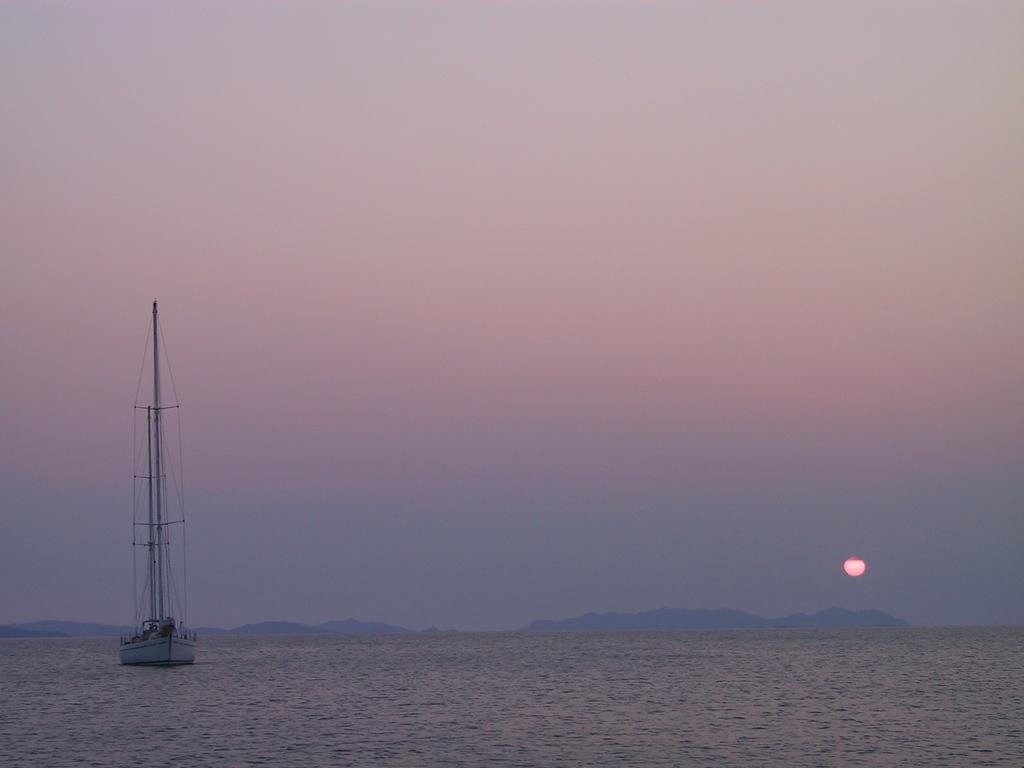What is the main subject of the image? The main subject of the image is a boat. What color is the boat? The boat is white in color. Where is the boat located in the image? The boat is on the surface of the water. What can be seen in the background of the image? Mountains and the sky are visible in the background of the image. Can the sun be seen in the sky? Yes, the sun is observable in the sky. What type of drug is being sold by the person standing on the boat in the image? There is no person standing on the boat in the image, and no drug is mentioned or visible. 